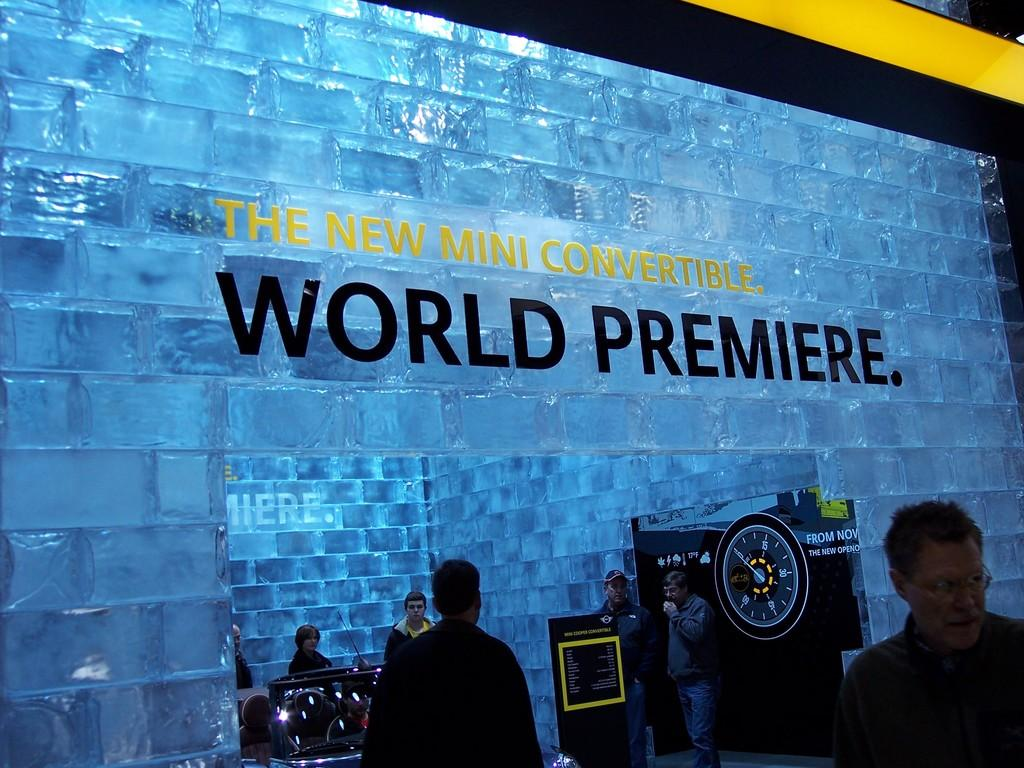What is happening in the image? There are people standing in the image. What is the store made of? The store appears to be made of ice cubes. What can be found inside the store? There is equipment inside the store. What type of soup is being served in the store? There is no soup present in the image, as the store is made of ice cubes and there is no indication of food or drink being served. 